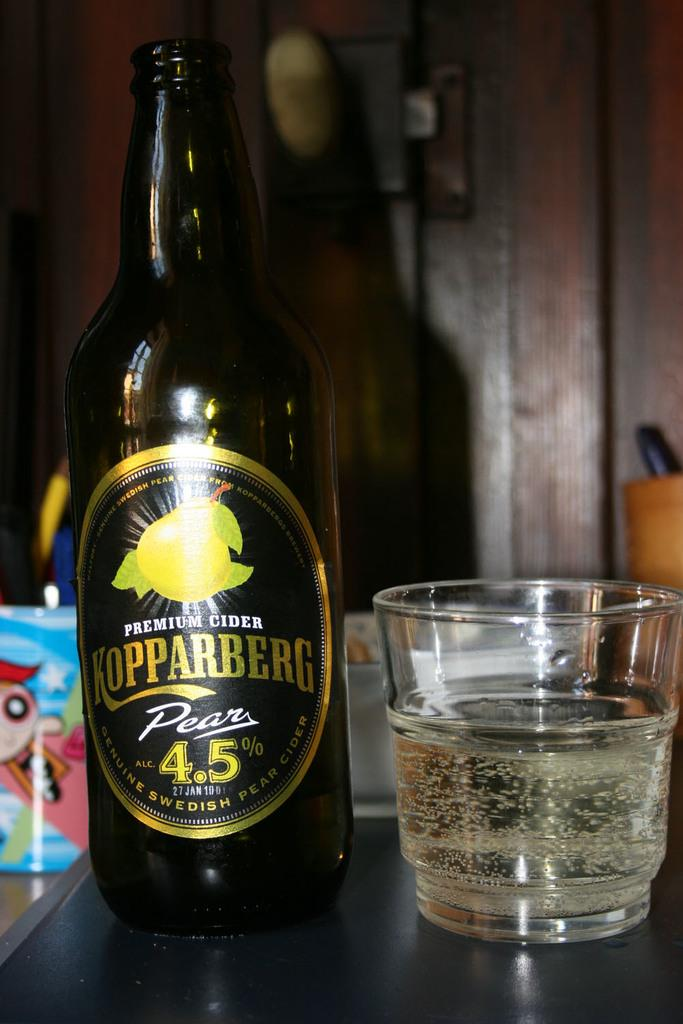Provide a one-sentence caption for the provided image. A bottle of Koppaberg Pear beer has been poured into a glass. 